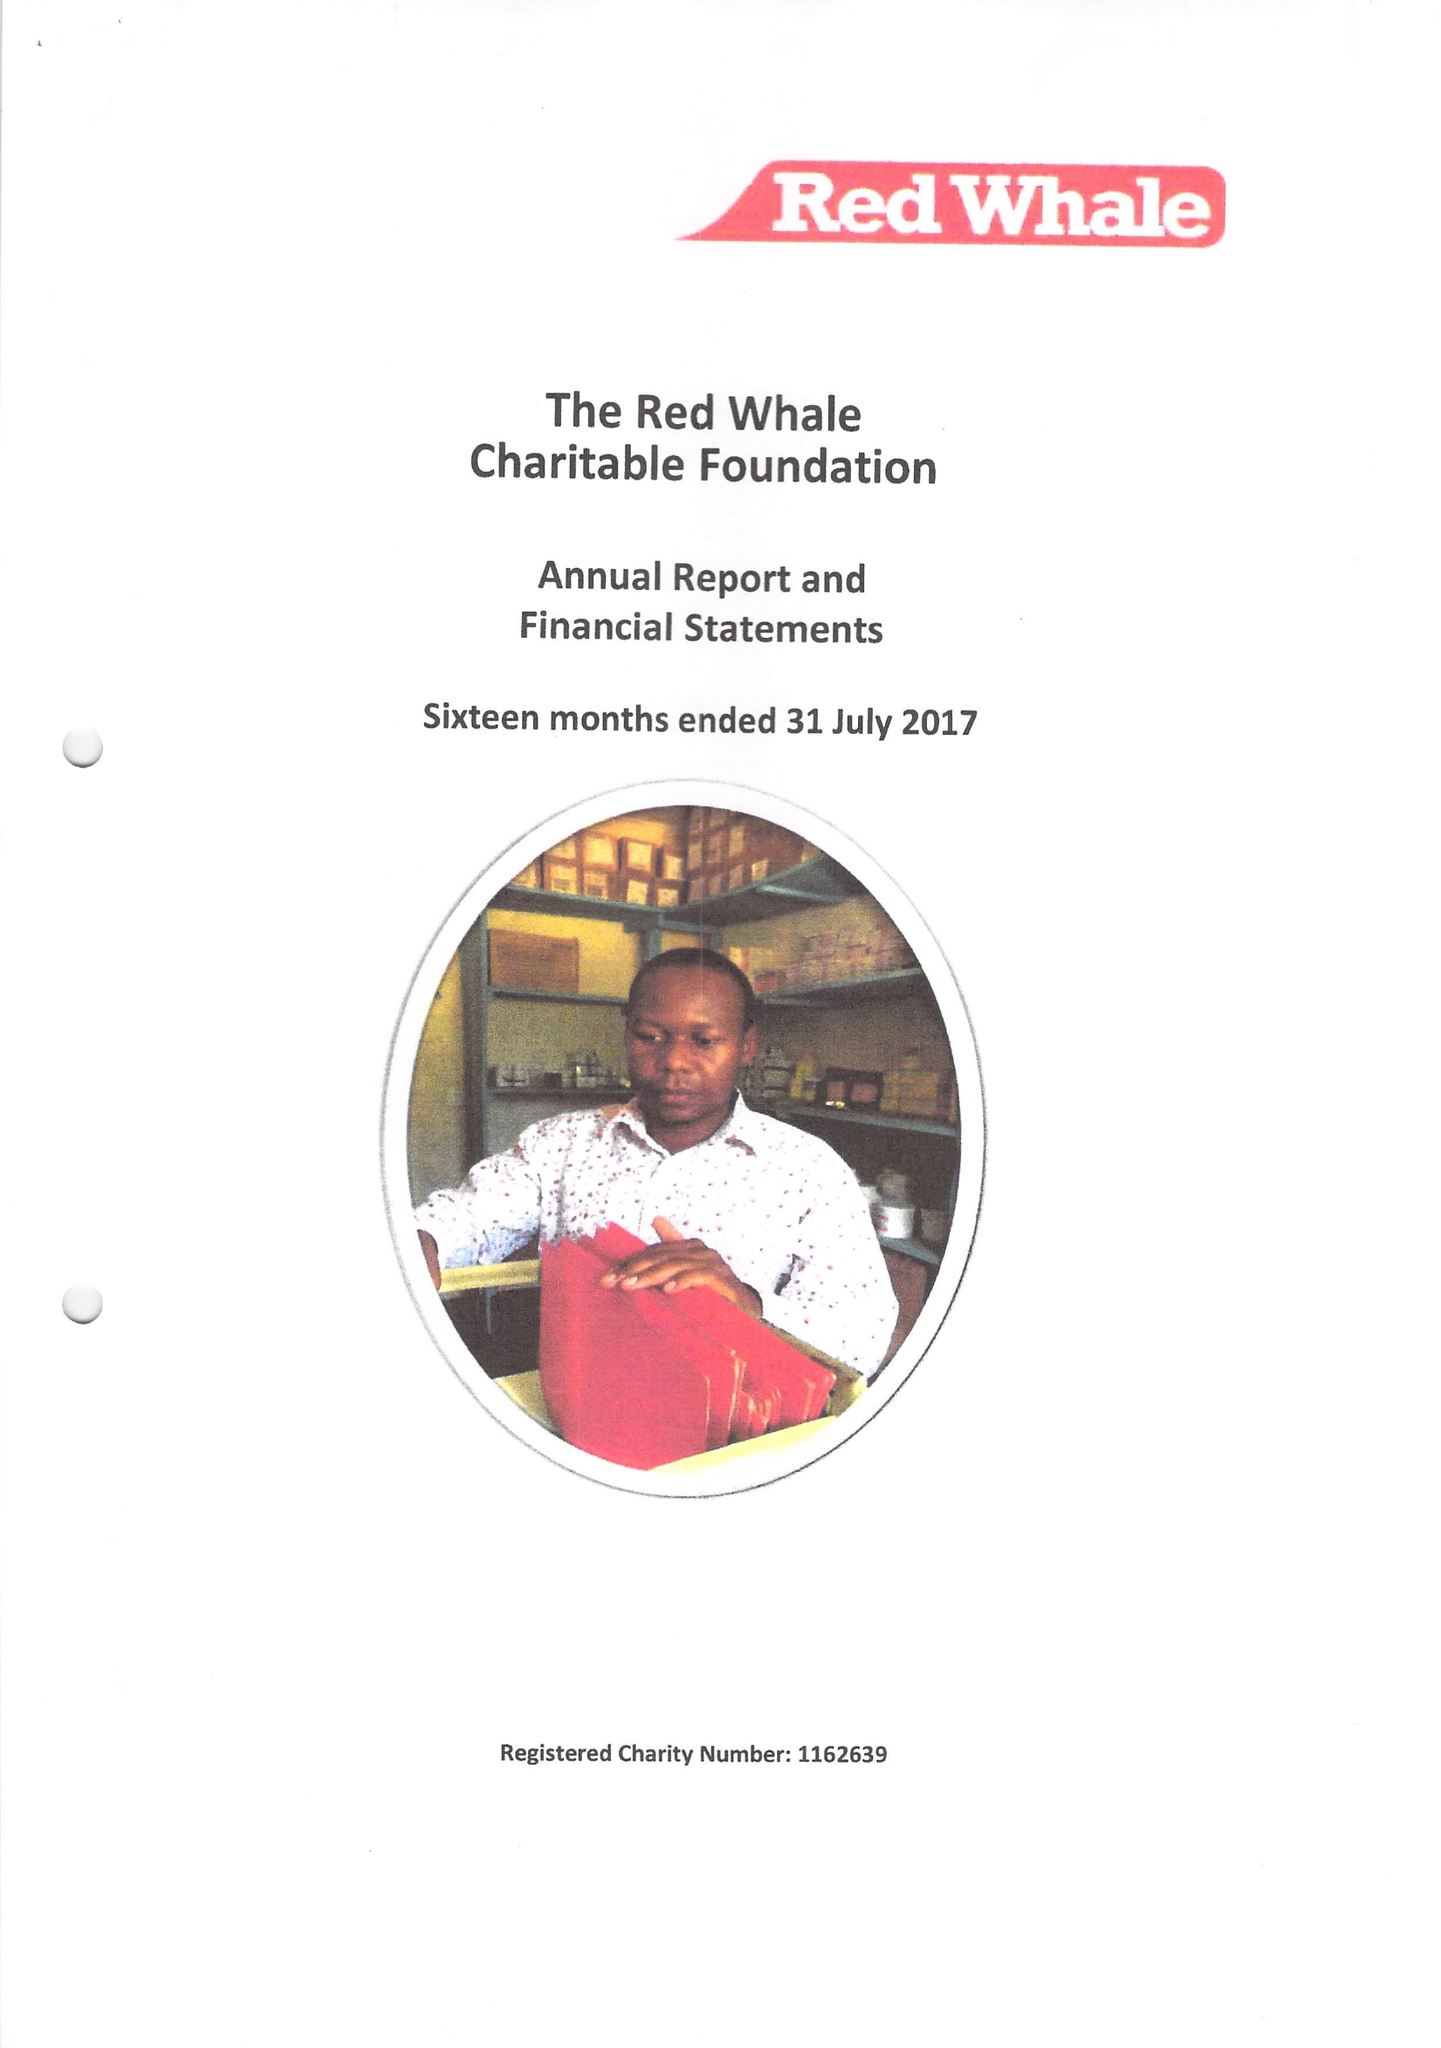What is the value for the charity_name?
Answer the question using a single word or phrase. The Red Whale Charitable Foundation 